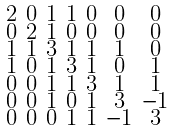<formula> <loc_0><loc_0><loc_500><loc_500>\begin{smallmatrix} 2 & 0 & 1 & 1 & 0 & 0 & 0 \\ 0 & 2 & 1 & 0 & 0 & 0 & 0 \\ 1 & 1 & 3 & 1 & 1 & 1 & 0 \\ 1 & 0 & 1 & 3 & 1 & 0 & 1 \\ 0 & 0 & 1 & 1 & 3 & 1 & 1 \\ 0 & 0 & 1 & 0 & 1 & 3 & - 1 \\ 0 & 0 & 0 & 1 & 1 & - 1 & 3 \end{smallmatrix}</formula> 